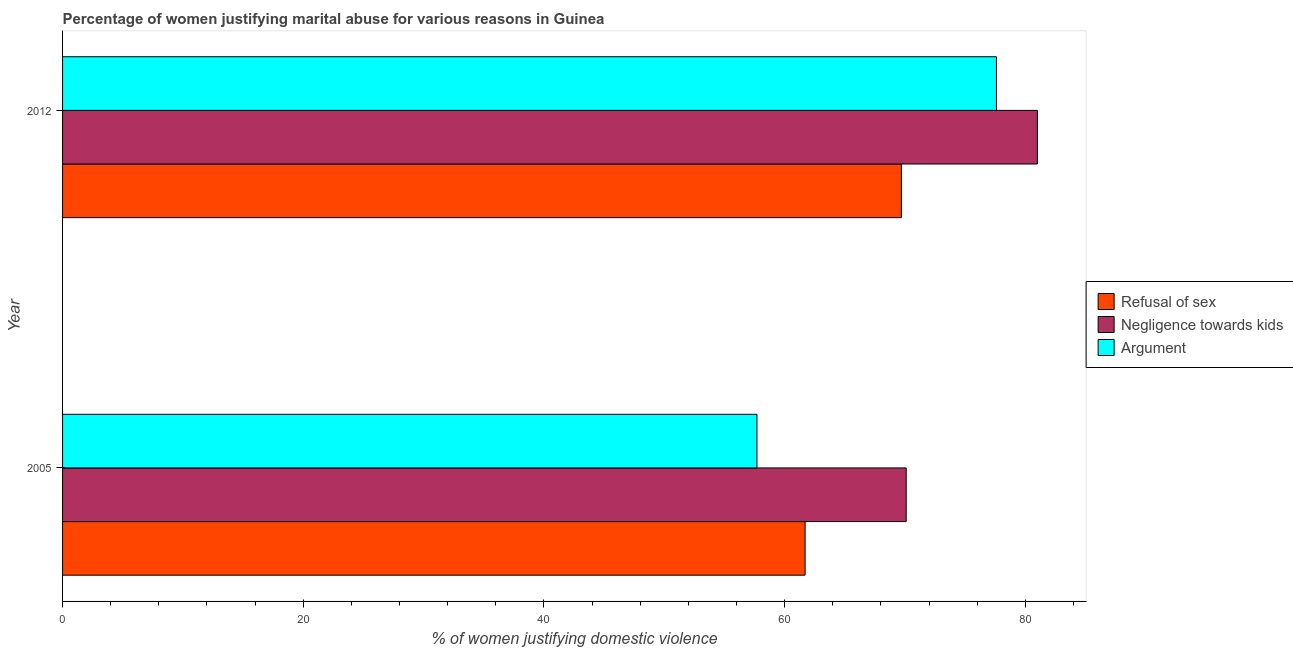How many groups of bars are there?
Ensure brevity in your answer.  2. Are the number of bars on each tick of the Y-axis equal?
Keep it short and to the point. Yes. What is the label of the 2nd group of bars from the top?
Your answer should be very brief. 2005. What is the percentage of women justifying domestic violence due to refusal of sex in 2005?
Offer a terse response. 61.7. Across all years, what is the maximum percentage of women justifying domestic violence due to arguments?
Keep it short and to the point. 77.6. Across all years, what is the minimum percentage of women justifying domestic violence due to refusal of sex?
Ensure brevity in your answer.  61.7. In which year was the percentage of women justifying domestic violence due to negligence towards kids maximum?
Make the answer very short. 2012. What is the total percentage of women justifying domestic violence due to arguments in the graph?
Your answer should be very brief. 135.3. What is the difference between the percentage of women justifying domestic violence due to arguments in 2005 and that in 2012?
Keep it short and to the point. -19.9. What is the average percentage of women justifying domestic violence due to refusal of sex per year?
Your answer should be very brief. 65.7. In the year 2012, what is the difference between the percentage of women justifying domestic violence due to arguments and percentage of women justifying domestic violence due to negligence towards kids?
Your response must be concise. -3.4. In how many years, is the percentage of women justifying domestic violence due to refusal of sex greater than 40 %?
Your answer should be very brief. 2. What is the ratio of the percentage of women justifying domestic violence due to arguments in 2005 to that in 2012?
Your response must be concise. 0.74. Is the percentage of women justifying domestic violence due to refusal of sex in 2005 less than that in 2012?
Give a very brief answer. Yes. What does the 3rd bar from the top in 2005 represents?
Your response must be concise. Refusal of sex. What does the 1st bar from the bottom in 2012 represents?
Provide a short and direct response. Refusal of sex. Is it the case that in every year, the sum of the percentage of women justifying domestic violence due to refusal of sex and percentage of women justifying domestic violence due to negligence towards kids is greater than the percentage of women justifying domestic violence due to arguments?
Make the answer very short. Yes. How many bars are there?
Keep it short and to the point. 6. Where does the legend appear in the graph?
Ensure brevity in your answer.  Center right. How many legend labels are there?
Ensure brevity in your answer.  3. What is the title of the graph?
Provide a succinct answer. Percentage of women justifying marital abuse for various reasons in Guinea. Does "Natural Gas" appear as one of the legend labels in the graph?
Your response must be concise. No. What is the label or title of the X-axis?
Your answer should be compact. % of women justifying domestic violence. What is the label or title of the Y-axis?
Provide a short and direct response. Year. What is the % of women justifying domestic violence of Refusal of sex in 2005?
Your answer should be very brief. 61.7. What is the % of women justifying domestic violence of Negligence towards kids in 2005?
Ensure brevity in your answer.  70.1. What is the % of women justifying domestic violence in Argument in 2005?
Keep it short and to the point. 57.7. What is the % of women justifying domestic violence of Refusal of sex in 2012?
Provide a short and direct response. 69.7. What is the % of women justifying domestic violence of Negligence towards kids in 2012?
Keep it short and to the point. 81. What is the % of women justifying domestic violence in Argument in 2012?
Make the answer very short. 77.6. Across all years, what is the maximum % of women justifying domestic violence of Refusal of sex?
Provide a succinct answer. 69.7. Across all years, what is the maximum % of women justifying domestic violence of Negligence towards kids?
Ensure brevity in your answer.  81. Across all years, what is the maximum % of women justifying domestic violence of Argument?
Make the answer very short. 77.6. Across all years, what is the minimum % of women justifying domestic violence in Refusal of sex?
Keep it short and to the point. 61.7. Across all years, what is the minimum % of women justifying domestic violence in Negligence towards kids?
Your answer should be compact. 70.1. Across all years, what is the minimum % of women justifying domestic violence in Argument?
Your response must be concise. 57.7. What is the total % of women justifying domestic violence of Refusal of sex in the graph?
Your answer should be very brief. 131.4. What is the total % of women justifying domestic violence in Negligence towards kids in the graph?
Offer a very short reply. 151.1. What is the total % of women justifying domestic violence of Argument in the graph?
Ensure brevity in your answer.  135.3. What is the difference between the % of women justifying domestic violence in Refusal of sex in 2005 and that in 2012?
Keep it short and to the point. -8. What is the difference between the % of women justifying domestic violence in Argument in 2005 and that in 2012?
Your response must be concise. -19.9. What is the difference between the % of women justifying domestic violence of Refusal of sex in 2005 and the % of women justifying domestic violence of Negligence towards kids in 2012?
Offer a very short reply. -19.3. What is the difference between the % of women justifying domestic violence in Refusal of sex in 2005 and the % of women justifying domestic violence in Argument in 2012?
Your answer should be very brief. -15.9. What is the difference between the % of women justifying domestic violence in Negligence towards kids in 2005 and the % of women justifying domestic violence in Argument in 2012?
Offer a terse response. -7.5. What is the average % of women justifying domestic violence in Refusal of sex per year?
Provide a succinct answer. 65.7. What is the average % of women justifying domestic violence in Negligence towards kids per year?
Provide a succinct answer. 75.55. What is the average % of women justifying domestic violence of Argument per year?
Your response must be concise. 67.65. In the year 2005, what is the difference between the % of women justifying domestic violence of Negligence towards kids and % of women justifying domestic violence of Argument?
Your response must be concise. 12.4. In the year 2012, what is the difference between the % of women justifying domestic violence in Refusal of sex and % of women justifying domestic violence in Negligence towards kids?
Provide a short and direct response. -11.3. In the year 2012, what is the difference between the % of women justifying domestic violence in Negligence towards kids and % of women justifying domestic violence in Argument?
Your answer should be compact. 3.4. What is the ratio of the % of women justifying domestic violence of Refusal of sex in 2005 to that in 2012?
Offer a very short reply. 0.89. What is the ratio of the % of women justifying domestic violence of Negligence towards kids in 2005 to that in 2012?
Make the answer very short. 0.87. What is the ratio of the % of women justifying domestic violence in Argument in 2005 to that in 2012?
Keep it short and to the point. 0.74. What is the difference between the highest and the second highest % of women justifying domestic violence in Refusal of sex?
Your answer should be very brief. 8. What is the difference between the highest and the second highest % of women justifying domestic violence of Negligence towards kids?
Offer a very short reply. 10.9. What is the difference between the highest and the lowest % of women justifying domestic violence in Negligence towards kids?
Your response must be concise. 10.9. 